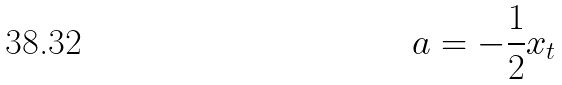Convert formula to latex. <formula><loc_0><loc_0><loc_500><loc_500>a = - \frac { 1 } { 2 } x _ { t }</formula> 